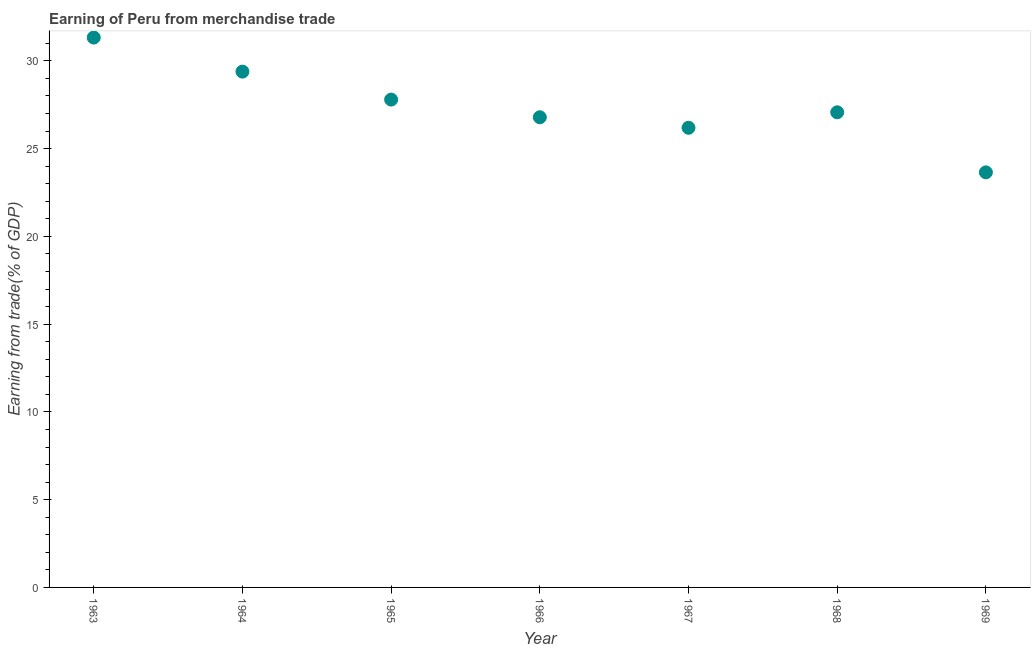What is the earning from merchandise trade in 1963?
Your answer should be very brief. 31.33. Across all years, what is the maximum earning from merchandise trade?
Provide a short and direct response. 31.33. Across all years, what is the minimum earning from merchandise trade?
Your response must be concise. 23.65. In which year was the earning from merchandise trade minimum?
Your answer should be very brief. 1969. What is the sum of the earning from merchandise trade?
Your answer should be very brief. 192.21. What is the difference between the earning from merchandise trade in 1963 and 1968?
Make the answer very short. 4.26. What is the average earning from merchandise trade per year?
Your response must be concise. 27.46. What is the median earning from merchandise trade?
Your answer should be compact. 27.07. In how many years, is the earning from merchandise trade greater than 5 %?
Your answer should be very brief. 7. Do a majority of the years between 1969 and 1963 (inclusive) have earning from merchandise trade greater than 24 %?
Provide a short and direct response. Yes. What is the ratio of the earning from merchandise trade in 1963 to that in 1965?
Provide a succinct answer. 1.13. Is the earning from merchandise trade in 1967 less than that in 1968?
Your answer should be compact. Yes. What is the difference between the highest and the second highest earning from merchandise trade?
Offer a terse response. 1.94. What is the difference between the highest and the lowest earning from merchandise trade?
Your answer should be compact. 7.68. In how many years, is the earning from merchandise trade greater than the average earning from merchandise trade taken over all years?
Provide a short and direct response. 3. Does the earning from merchandise trade monotonically increase over the years?
Provide a short and direct response. No. How many dotlines are there?
Provide a short and direct response. 1. How many years are there in the graph?
Make the answer very short. 7. Does the graph contain grids?
Your answer should be very brief. No. What is the title of the graph?
Provide a short and direct response. Earning of Peru from merchandise trade. What is the label or title of the X-axis?
Keep it short and to the point. Year. What is the label or title of the Y-axis?
Make the answer very short. Earning from trade(% of GDP). What is the Earning from trade(% of GDP) in 1963?
Provide a succinct answer. 31.33. What is the Earning from trade(% of GDP) in 1964?
Offer a very short reply. 29.39. What is the Earning from trade(% of GDP) in 1965?
Your response must be concise. 27.79. What is the Earning from trade(% of GDP) in 1966?
Give a very brief answer. 26.79. What is the Earning from trade(% of GDP) in 1967?
Offer a terse response. 26.19. What is the Earning from trade(% of GDP) in 1968?
Provide a short and direct response. 27.07. What is the Earning from trade(% of GDP) in 1969?
Your response must be concise. 23.65. What is the difference between the Earning from trade(% of GDP) in 1963 and 1964?
Your answer should be very brief. 1.94. What is the difference between the Earning from trade(% of GDP) in 1963 and 1965?
Offer a very short reply. 3.53. What is the difference between the Earning from trade(% of GDP) in 1963 and 1966?
Keep it short and to the point. 4.54. What is the difference between the Earning from trade(% of GDP) in 1963 and 1967?
Keep it short and to the point. 5.14. What is the difference between the Earning from trade(% of GDP) in 1963 and 1968?
Ensure brevity in your answer.  4.26. What is the difference between the Earning from trade(% of GDP) in 1963 and 1969?
Keep it short and to the point. 7.68. What is the difference between the Earning from trade(% of GDP) in 1964 and 1965?
Provide a succinct answer. 1.59. What is the difference between the Earning from trade(% of GDP) in 1964 and 1966?
Make the answer very short. 2.6. What is the difference between the Earning from trade(% of GDP) in 1964 and 1967?
Ensure brevity in your answer.  3.2. What is the difference between the Earning from trade(% of GDP) in 1964 and 1968?
Ensure brevity in your answer.  2.32. What is the difference between the Earning from trade(% of GDP) in 1964 and 1969?
Your answer should be very brief. 5.74. What is the difference between the Earning from trade(% of GDP) in 1965 and 1966?
Your answer should be very brief. 1.01. What is the difference between the Earning from trade(% of GDP) in 1965 and 1967?
Provide a short and direct response. 1.61. What is the difference between the Earning from trade(% of GDP) in 1965 and 1968?
Make the answer very short. 0.72. What is the difference between the Earning from trade(% of GDP) in 1965 and 1969?
Give a very brief answer. 4.15. What is the difference between the Earning from trade(% of GDP) in 1966 and 1967?
Ensure brevity in your answer.  0.6. What is the difference between the Earning from trade(% of GDP) in 1966 and 1968?
Provide a succinct answer. -0.28. What is the difference between the Earning from trade(% of GDP) in 1966 and 1969?
Give a very brief answer. 3.14. What is the difference between the Earning from trade(% of GDP) in 1967 and 1968?
Your response must be concise. -0.88. What is the difference between the Earning from trade(% of GDP) in 1967 and 1969?
Your response must be concise. 2.54. What is the difference between the Earning from trade(% of GDP) in 1968 and 1969?
Ensure brevity in your answer.  3.42. What is the ratio of the Earning from trade(% of GDP) in 1963 to that in 1964?
Make the answer very short. 1.07. What is the ratio of the Earning from trade(% of GDP) in 1963 to that in 1965?
Give a very brief answer. 1.13. What is the ratio of the Earning from trade(% of GDP) in 1963 to that in 1966?
Offer a very short reply. 1.17. What is the ratio of the Earning from trade(% of GDP) in 1963 to that in 1967?
Give a very brief answer. 1.2. What is the ratio of the Earning from trade(% of GDP) in 1963 to that in 1968?
Ensure brevity in your answer.  1.16. What is the ratio of the Earning from trade(% of GDP) in 1963 to that in 1969?
Offer a very short reply. 1.32. What is the ratio of the Earning from trade(% of GDP) in 1964 to that in 1965?
Your answer should be compact. 1.06. What is the ratio of the Earning from trade(% of GDP) in 1964 to that in 1966?
Your answer should be very brief. 1.1. What is the ratio of the Earning from trade(% of GDP) in 1964 to that in 1967?
Your answer should be compact. 1.12. What is the ratio of the Earning from trade(% of GDP) in 1964 to that in 1968?
Offer a terse response. 1.09. What is the ratio of the Earning from trade(% of GDP) in 1964 to that in 1969?
Keep it short and to the point. 1.24. What is the ratio of the Earning from trade(% of GDP) in 1965 to that in 1966?
Your response must be concise. 1.04. What is the ratio of the Earning from trade(% of GDP) in 1965 to that in 1967?
Give a very brief answer. 1.06. What is the ratio of the Earning from trade(% of GDP) in 1965 to that in 1968?
Offer a terse response. 1.03. What is the ratio of the Earning from trade(% of GDP) in 1965 to that in 1969?
Your response must be concise. 1.18. What is the ratio of the Earning from trade(% of GDP) in 1966 to that in 1968?
Provide a succinct answer. 0.99. What is the ratio of the Earning from trade(% of GDP) in 1966 to that in 1969?
Offer a very short reply. 1.13. What is the ratio of the Earning from trade(% of GDP) in 1967 to that in 1969?
Provide a short and direct response. 1.11. What is the ratio of the Earning from trade(% of GDP) in 1968 to that in 1969?
Provide a short and direct response. 1.15. 